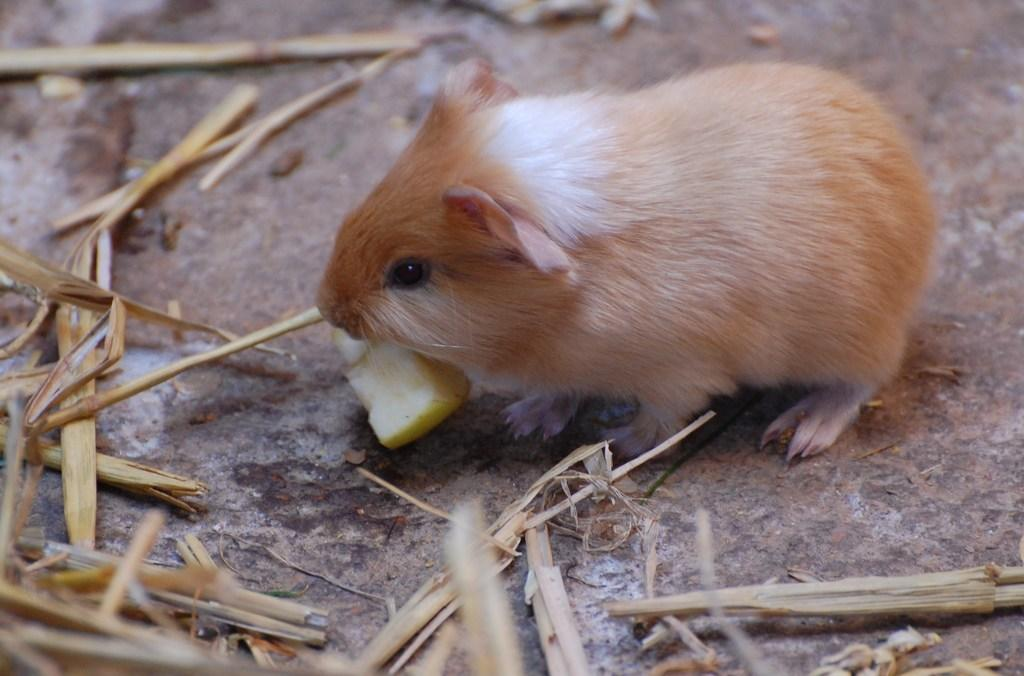What type of animal is in the image? There is a Guinea Pig in the image. What is on the ground near the Guinea Pig? There is a food item and grass on the ground in the image. Can you hear the baby laughing in the image? There is no baby or laughter present in the image; it only features a Guinea Pig and items on the ground. 